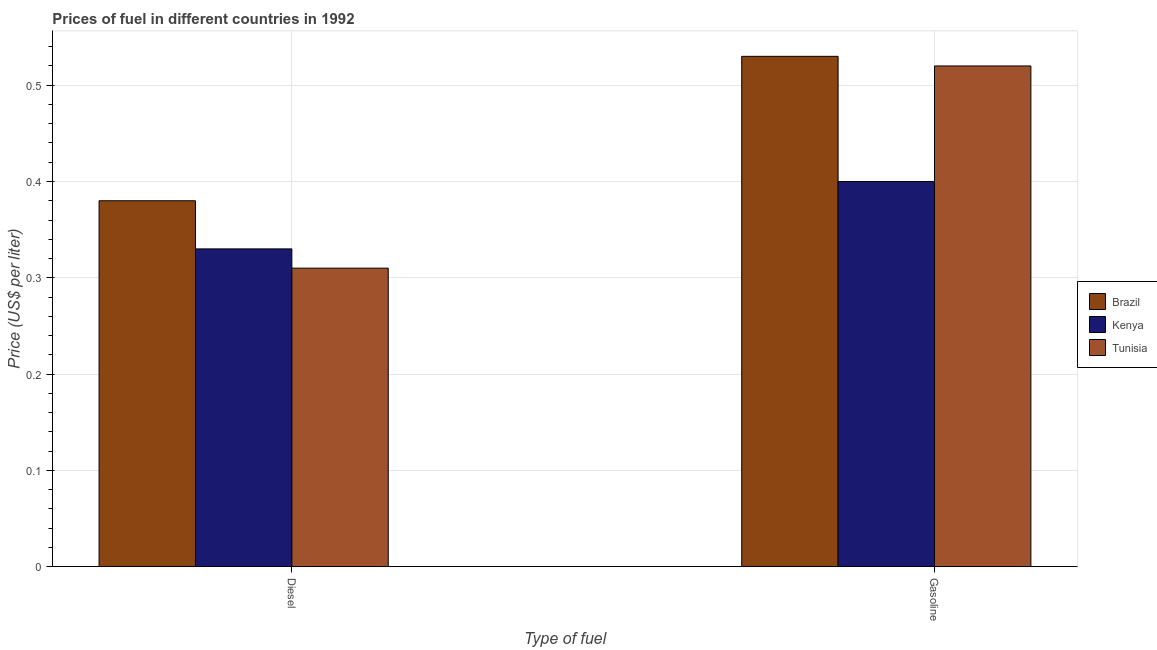How many different coloured bars are there?
Your response must be concise. 3. How many groups of bars are there?
Provide a short and direct response. 2. Are the number of bars on each tick of the X-axis equal?
Provide a short and direct response. Yes. What is the label of the 2nd group of bars from the left?
Keep it short and to the point. Gasoline. What is the gasoline price in Brazil?
Make the answer very short. 0.53. Across all countries, what is the maximum diesel price?
Your answer should be compact. 0.38. Across all countries, what is the minimum diesel price?
Ensure brevity in your answer.  0.31. In which country was the gasoline price minimum?
Give a very brief answer. Kenya. What is the total gasoline price in the graph?
Provide a succinct answer. 1.45. What is the difference between the diesel price in Kenya and that in Tunisia?
Keep it short and to the point. 0.02. What is the difference between the gasoline price in Tunisia and the diesel price in Kenya?
Your answer should be compact. 0.19. What is the average gasoline price per country?
Your answer should be compact. 0.48. What is the difference between the gasoline price and diesel price in Brazil?
Your response must be concise. 0.15. What is the ratio of the gasoline price in Tunisia to that in Kenya?
Provide a short and direct response. 1.3. Is the gasoline price in Brazil less than that in Kenya?
Your response must be concise. No. What does the 2nd bar from the left in Gasoline represents?
Make the answer very short. Kenya. Are all the bars in the graph horizontal?
Offer a terse response. No. What is the difference between two consecutive major ticks on the Y-axis?
Keep it short and to the point. 0.1. Does the graph contain any zero values?
Your response must be concise. No. Does the graph contain grids?
Offer a terse response. Yes. Where does the legend appear in the graph?
Your answer should be very brief. Center right. How many legend labels are there?
Your answer should be very brief. 3. What is the title of the graph?
Offer a terse response. Prices of fuel in different countries in 1992. Does "Afghanistan" appear as one of the legend labels in the graph?
Your answer should be very brief. No. What is the label or title of the X-axis?
Provide a succinct answer. Type of fuel. What is the label or title of the Y-axis?
Provide a succinct answer. Price (US$ per liter). What is the Price (US$ per liter) of Brazil in Diesel?
Offer a very short reply. 0.38. What is the Price (US$ per liter) of Kenya in Diesel?
Give a very brief answer. 0.33. What is the Price (US$ per liter) of Tunisia in Diesel?
Give a very brief answer. 0.31. What is the Price (US$ per liter) of Brazil in Gasoline?
Provide a succinct answer. 0.53. What is the Price (US$ per liter) in Tunisia in Gasoline?
Keep it short and to the point. 0.52. Across all Type of fuel, what is the maximum Price (US$ per liter) of Brazil?
Provide a short and direct response. 0.53. Across all Type of fuel, what is the maximum Price (US$ per liter) of Kenya?
Your response must be concise. 0.4. Across all Type of fuel, what is the maximum Price (US$ per liter) of Tunisia?
Offer a terse response. 0.52. Across all Type of fuel, what is the minimum Price (US$ per liter) in Brazil?
Ensure brevity in your answer.  0.38. Across all Type of fuel, what is the minimum Price (US$ per liter) in Kenya?
Give a very brief answer. 0.33. Across all Type of fuel, what is the minimum Price (US$ per liter) in Tunisia?
Offer a terse response. 0.31. What is the total Price (US$ per liter) of Brazil in the graph?
Your answer should be very brief. 0.91. What is the total Price (US$ per liter) of Kenya in the graph?
Give a very brief answer. 0.73. What is the total Price (US$ per liter) of Tunisia in the graph?
Offer a terse response. 0.83. What is the difference between the Price (US$ per liter) in Kenya in Diesel and that in Gasoline?
Ensure brevity in your answer.  -0.07. What is the difference between the Price (US$ per liter) of Tunisia in Diesel and that in Gasoline?
Offer a terse response. -0.21. What is the difference between the Price (US$ per liter) of Brazil in Diesel and the Price (US$ per liter) of Kenya in Gasoline?
Your response must be concise. -0.02. What is the difference between the Price (US$ per liter) in Brazil in Diesel and the Price (US$ per liter) in Tunisia in Gasoline?
Your answer should be very brief. -0.14. What is the difference between the Price (US$ per liter) of Kenya in Diesel and the Price (US$ per liter) of Tunisia in Gasoline?
Ensure brevity in your answer.  -0.19. What is the average Price (US$ per liter) in Brazil per Type of fuel?
Provide a succinct answer. 0.46. What is the average Price (US$ per liter) in Kenya per Type of fuel?
Your response must be concise. 0.36. What is the average Price (US$ per liter) in Tunisia per Type of fuel?
Your response must be concise. 0.41. What is the difference between the Price (US$ per liter) of Brazil and Price (US$ per liter) of Tunisia in Diesel?
Keep it short and to the point. 0.07. What is the difference between the Price (US$ per liter) of Brazil and Price (US$ per liter) of Kenya in Gasoline?
Ensure brevity in your answer.  0.13. What is the difference between the Price (US$ per liter) in Brazil and Price (US$ per liter) in Tunisia in Gasoline?
Ensure brevity in your answer.  0.01. What is the difference between the Price (US$ per liter) in Kenya and Price (US$ per liter) in Tunisia in Gasoline?
Provide a short and direct response. -0.12. What is the ratio of the Price (US$ per liter) of Brazil in Diesel to that in Gasoline?
Ensure brevity in your answer.  0.72. What is the ratio of the Price (US$ per liter) of Kenya in Diesel to that in Gasoline?
Offer a very short reply. 0.82. What is the ratio of the Price (US$ per liter) in Tunisia in Diesel to that in Gasoline?
Provide a short and direct response. 0.6. What is the difference between the highest and the second highest Price (US$ per liter) of Kenya?
Your answer should be compact. 0.07. What is the difference between the highest and the second highest Price (US$ per liter) in Tunisia?
Offer a very short reply. 0.21. What is the difference between the highest and the lowest Price (US$ per liter) of Kenya?
Make the answer very short. 0.07. What is the difference between the highest and the lowest Price (US$ per liter) in Tunisia?
Give a very brief answer. 0.21. 